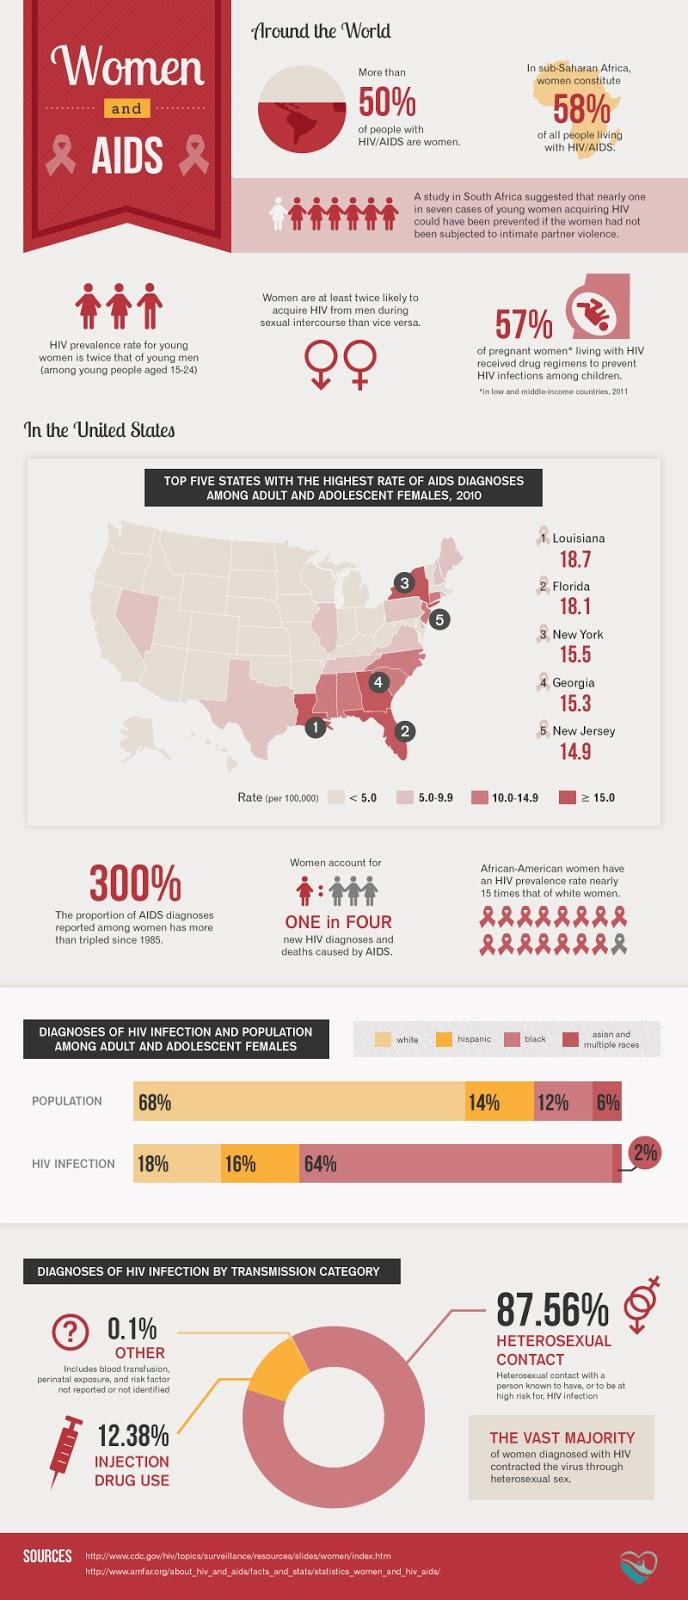Specify some key components in this picture. Four states have a rate of AIDS diagnoses that is greater than 15%. It is commonly believed that African Americans have the highest percentage of HIV infections among the three races mentioned. In sub-Saharan Africa, approximately 58% of women are living with HIV. The race that has the second highest number of HIV infections, but the largest percentage of the population, is white. In a study conducted on the transmission of HIV, it was found that only 0.1% of cases were not transmitted through heterosexual contact or injections. 